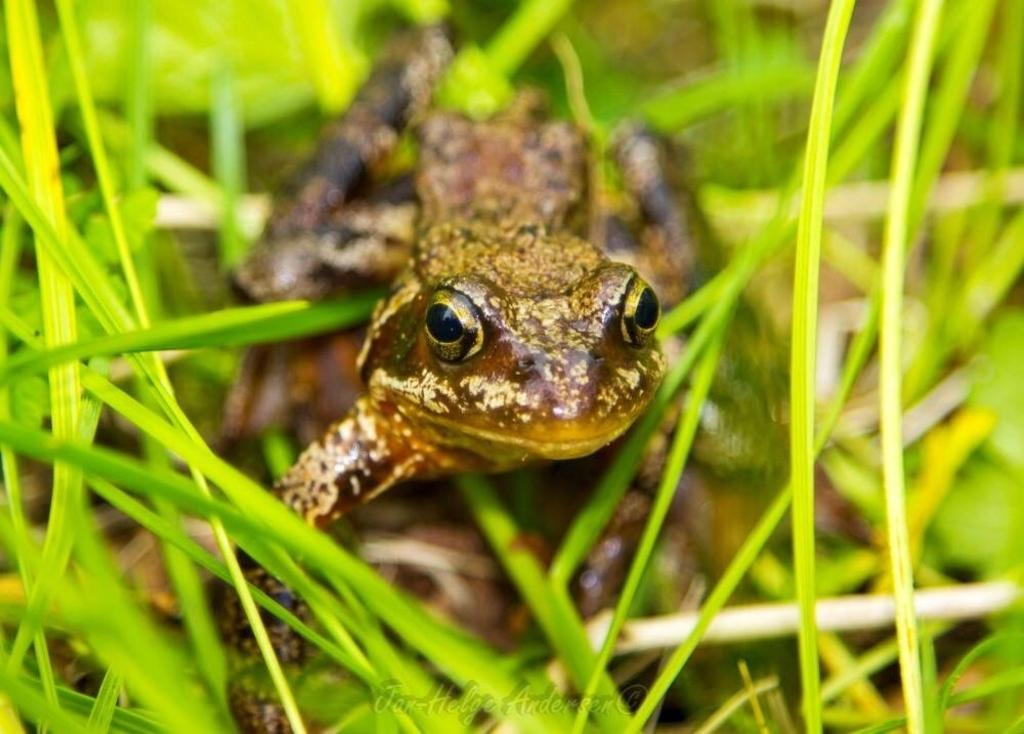How many frogs are in the image? There are two frogs in the image. What is the position of the frogs in relation to each other? One frog is on top of the other. What type of environment is visible in the image? There is grass visible in the image. Are the frogs smiling in the image? There is no indication of the frogs' facial expressions in the image, so it cannot be determined if they are smiling. 